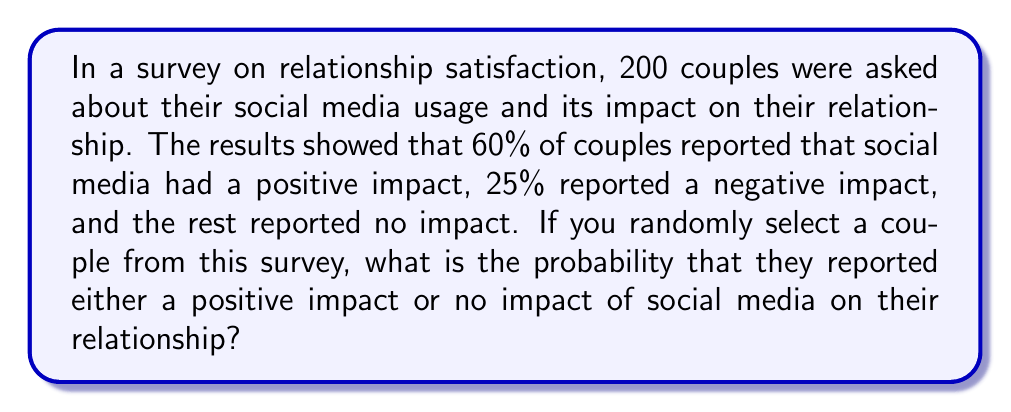What is the answer to this math problem? Let's approach this step-by-step:

1) First, let's identify the given information:
   - Total number of couples surveyed: 200
   - Couples reporting positive impact: 60%
   - Couples reporting negative impact: 25%
   - Couples reporting no impact: the rest

2) Calculate the percentage of couples reporting no impact:
   $100\% - 60\% - 25\% = 15\%$

3) Now, we need to find the probability of selecting a couple that reported either a positive impact or no impact. This is the sum of these two probabilities:

   $P(\text{positive or no impact}) = P(\text{positive}) + P(\text{no impact})$

4) We know that:
   $P(\text{positive}) = 60\% = 0.60$
   $P(\text{no impact}) = 15\% = 0.15$

5) Therefore:
   $P(\text{positive or no impact}) = 0.60 + 0.15 = 0.75$

6) We can also verify this by noting that it's the complement of the probability of negative impact:
   $1 - P(\text{negative}) = 1 - 0.25 = 0.75$

Thus, the probability of randomly selecting a couple that reported either a positive impact or no impact is 0.75 or 75%.
Answer: 0.75 